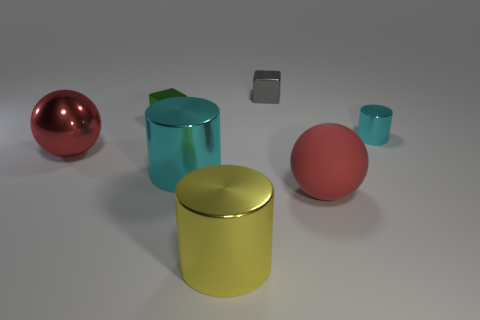The large ball that is the same material as the green object is what color?
Make the answer very short. Red. Is the number of red shiny objects that are in front of the rubber thing less than the number of tiny cyan things behind the tiny cylinder?
Ensure brevity in your answer.  No. How many other large things have the same color as the matte object?
Give a very brief answer. 1. There is another big thing that is the same color as the big matte thing; what material is it?
Give a very brief answer. Metal. What is the material of the cyan object that is the same size as the yellow metal thing?
Your answer should be very brief. Metal. There is another large object that is the same shape as the red rubber thing; what is its material?
Ensure brevity in your answer.  Metal. How many objects are metal blocks to the left of the yellow object or large metallic things that are left of the tiny gray shiny block?
Provide a succinct answer. 4. There is a big matte ball; is its color the same as the ball to the left of the matte object?
Provide a short and direct response. Yes. What is the shape of the red thing that is made of the same material as the small cyan cylinder?
Your answer should be very brief. Sphere. What number of tiny gray rubber things are there?
Give a very brief answer. 0. 